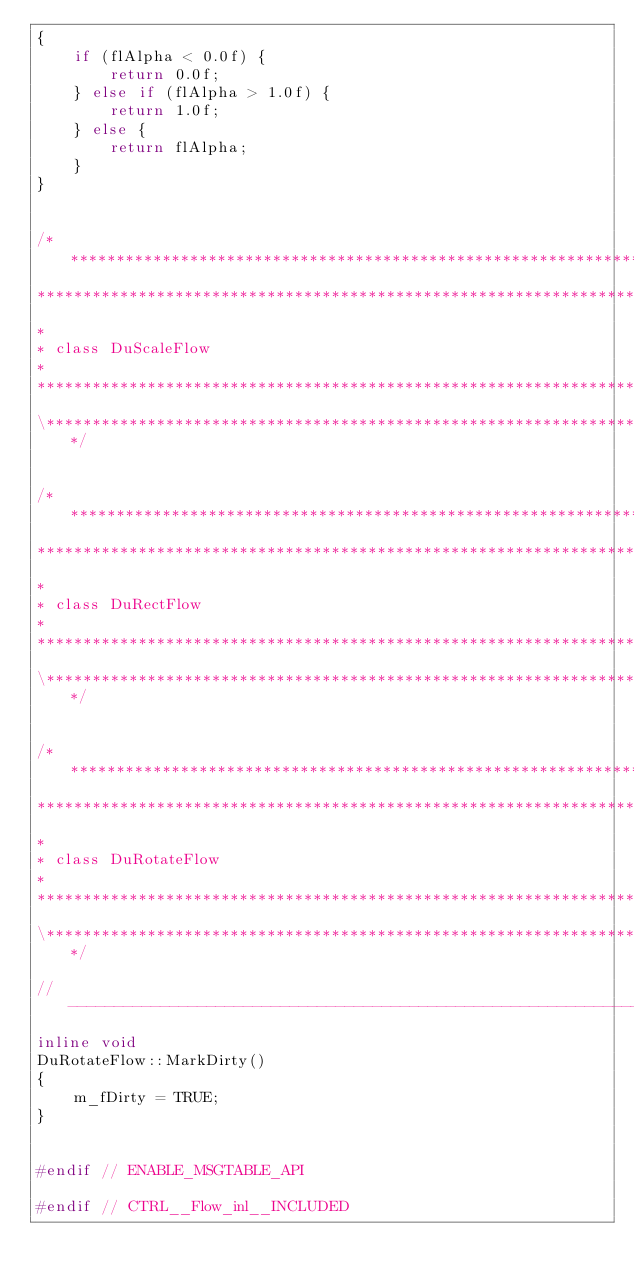<code> <loc_0><loc_0><loc_500><loc_500><_C++_>{
    if (flAlpha < 0.0f) {
        return 0.0f;
    } else if (flAlpha > 1.0f) {
        return 1.0f;
    } else {
        return flAlpha;
    }
}


/***************************************************************************\
*****************************************************************************
*
* class DuScaleFlow
*
*****************************************************************************
\***************************************************************************/


/***************************************************************************\
*****************************************************************************
*
* class DuRectFlow
*
*****************************************************************************
\***************************************************************************/


/***************************************************************************\
*****************************************************************************
*
* class DuRotateFlow
*
*****************************************************************************
\***************************************************************************/

//------------------------------------------------------------------------------
inline void
DuRotateFlow::MarkDirty()
{
    m_fDirty = TRUE;
}


#endif // ENABLE_MSGTABLE_API

#endif // CTRL__Flow_inl__INCLUDED
</code> 